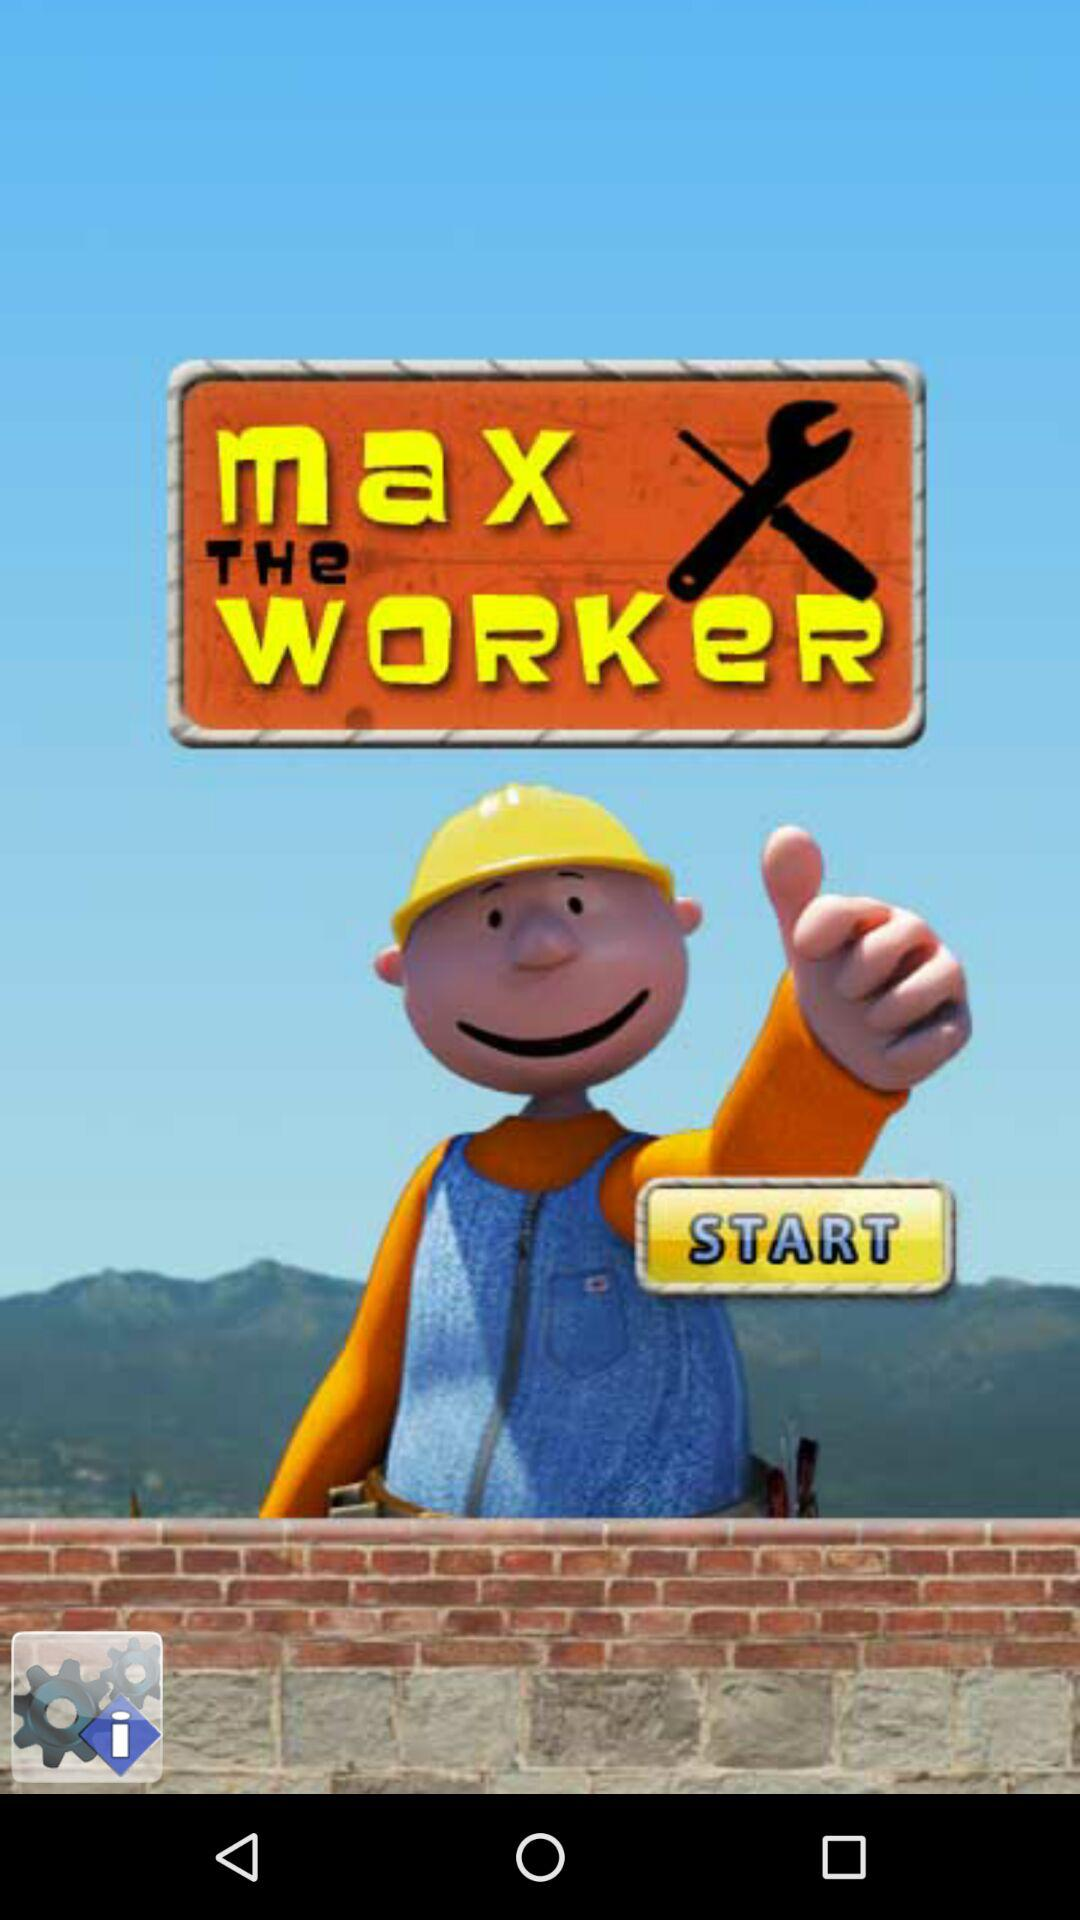What is the application name? The application name is "Max the Worker". 